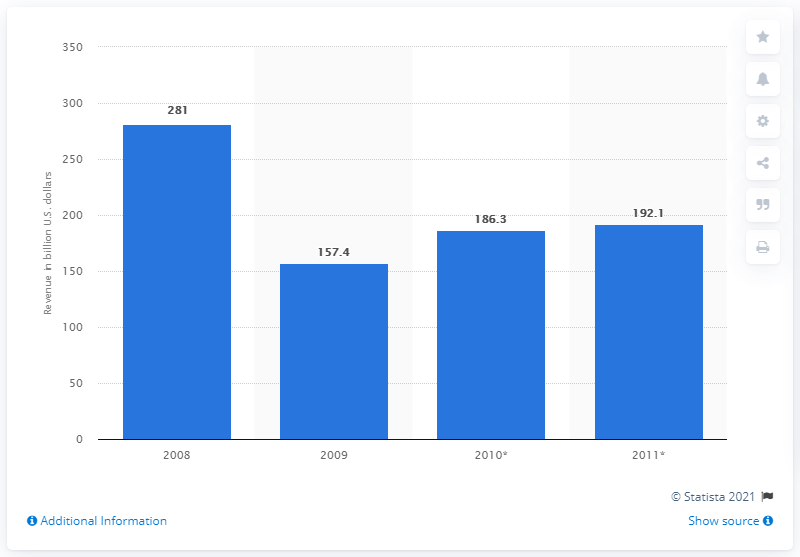Specify some key components in this picture. In 2009, Saudi Arabia generated approximately 157.4 billion US dollars from oil exports. 